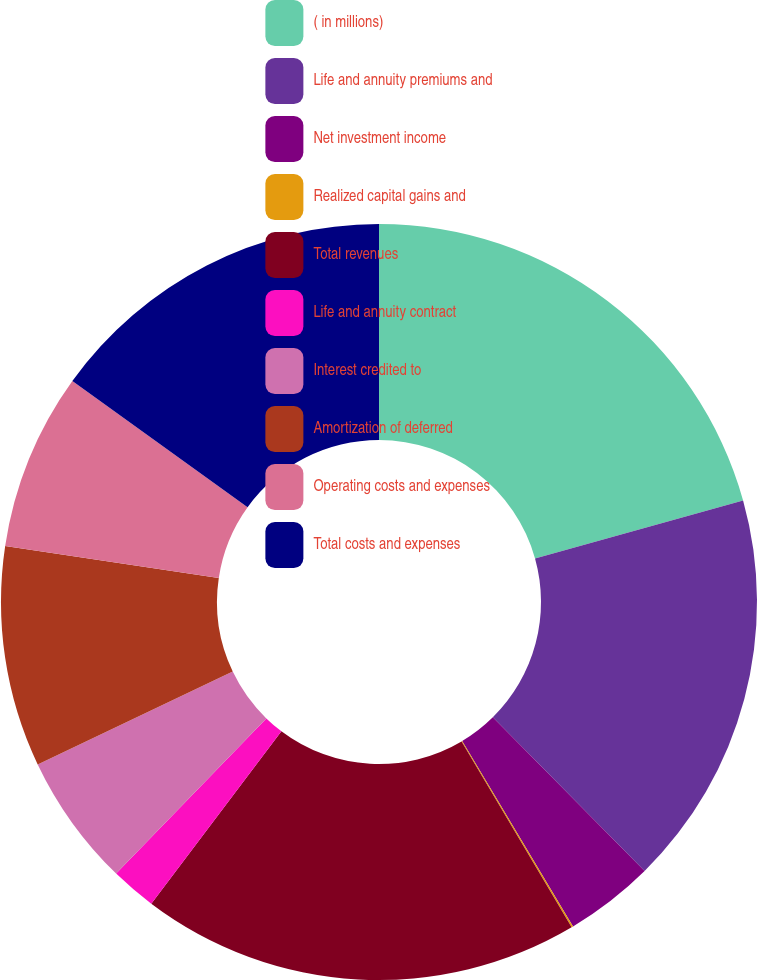<chart> <loc_0><loc_0><loc_500><loc_500><pie_chart><fcel>( in millions)<fcel>Life and annuity premiums and<fcel>Net investment income<fcel>Realized capital gains and<fcel>Total revenues<fcel>Life and annuity contract<fcel>Interest credited to<fcel>Amortization of deferred<fcel>Operating costs and expenses<fcel>Total costs and expenses<nl><fcel>20.67%<fcel>16.93%<fcel>3.82%<fcel>0.07%<fcel>18.8%<fcel>1.95%<fcel>5.69%<fcel>9.44%<fcel>7.57%<fcel>15.06%<nl></chart> 